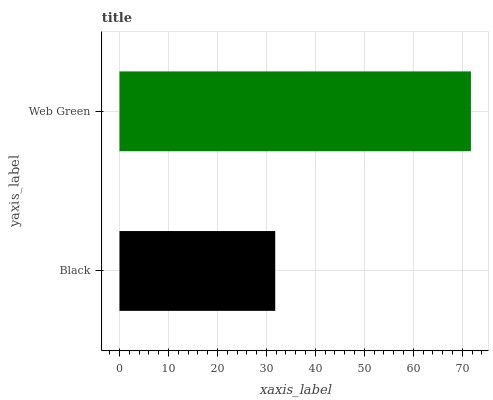Is Black the minimum?
Answer yes or no. Yes. Is Web Green the maximum?
Answer yes or no. Yes. Is Web Green the minimum?
Answer yes or no. No. Is Web Green greater than Black?
Answer yes or no. Yes. Is Black less than Web Green?
Answer yes or no. Yes. Is Black greater than Web Green?
Answer yes or no. No. Is Web Green less than Black?
Answer yes or no. No. Is Web Green the high median?
Answer yes or no. Yes. Is Black the low median?
Answer yes or no. Yes. Is Black the high median?
Answer yes or no. No. Is Web Green the low median?
Answer yes or no. No. 